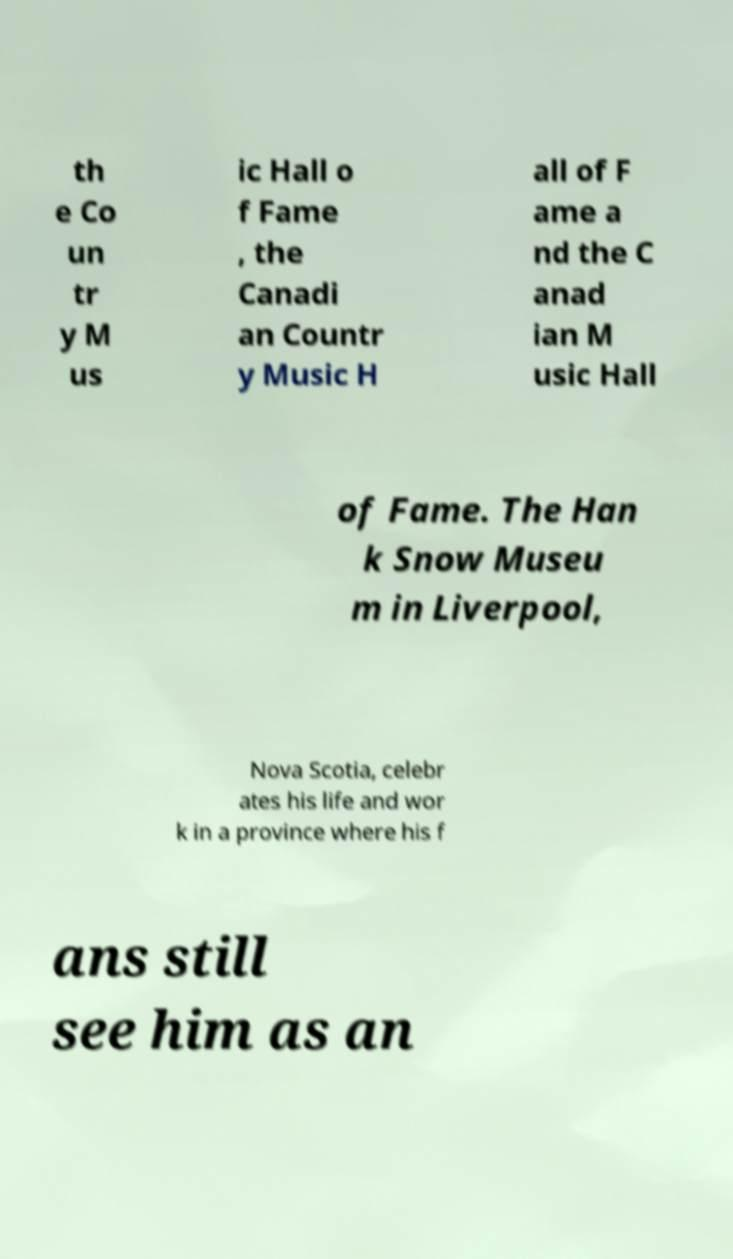Please read and relay the text visible in this image. What does it say? th e Co un tr y M us ic Hall o f Fame , the Canadi an Countr y Music H all of F ame a nd the C anad ian M usic Hall of Fame. The Han k Snow Museu m in Liverpool, Nova Scotia, celebr ates his life and wor k in a province where his f ans still see him as an 